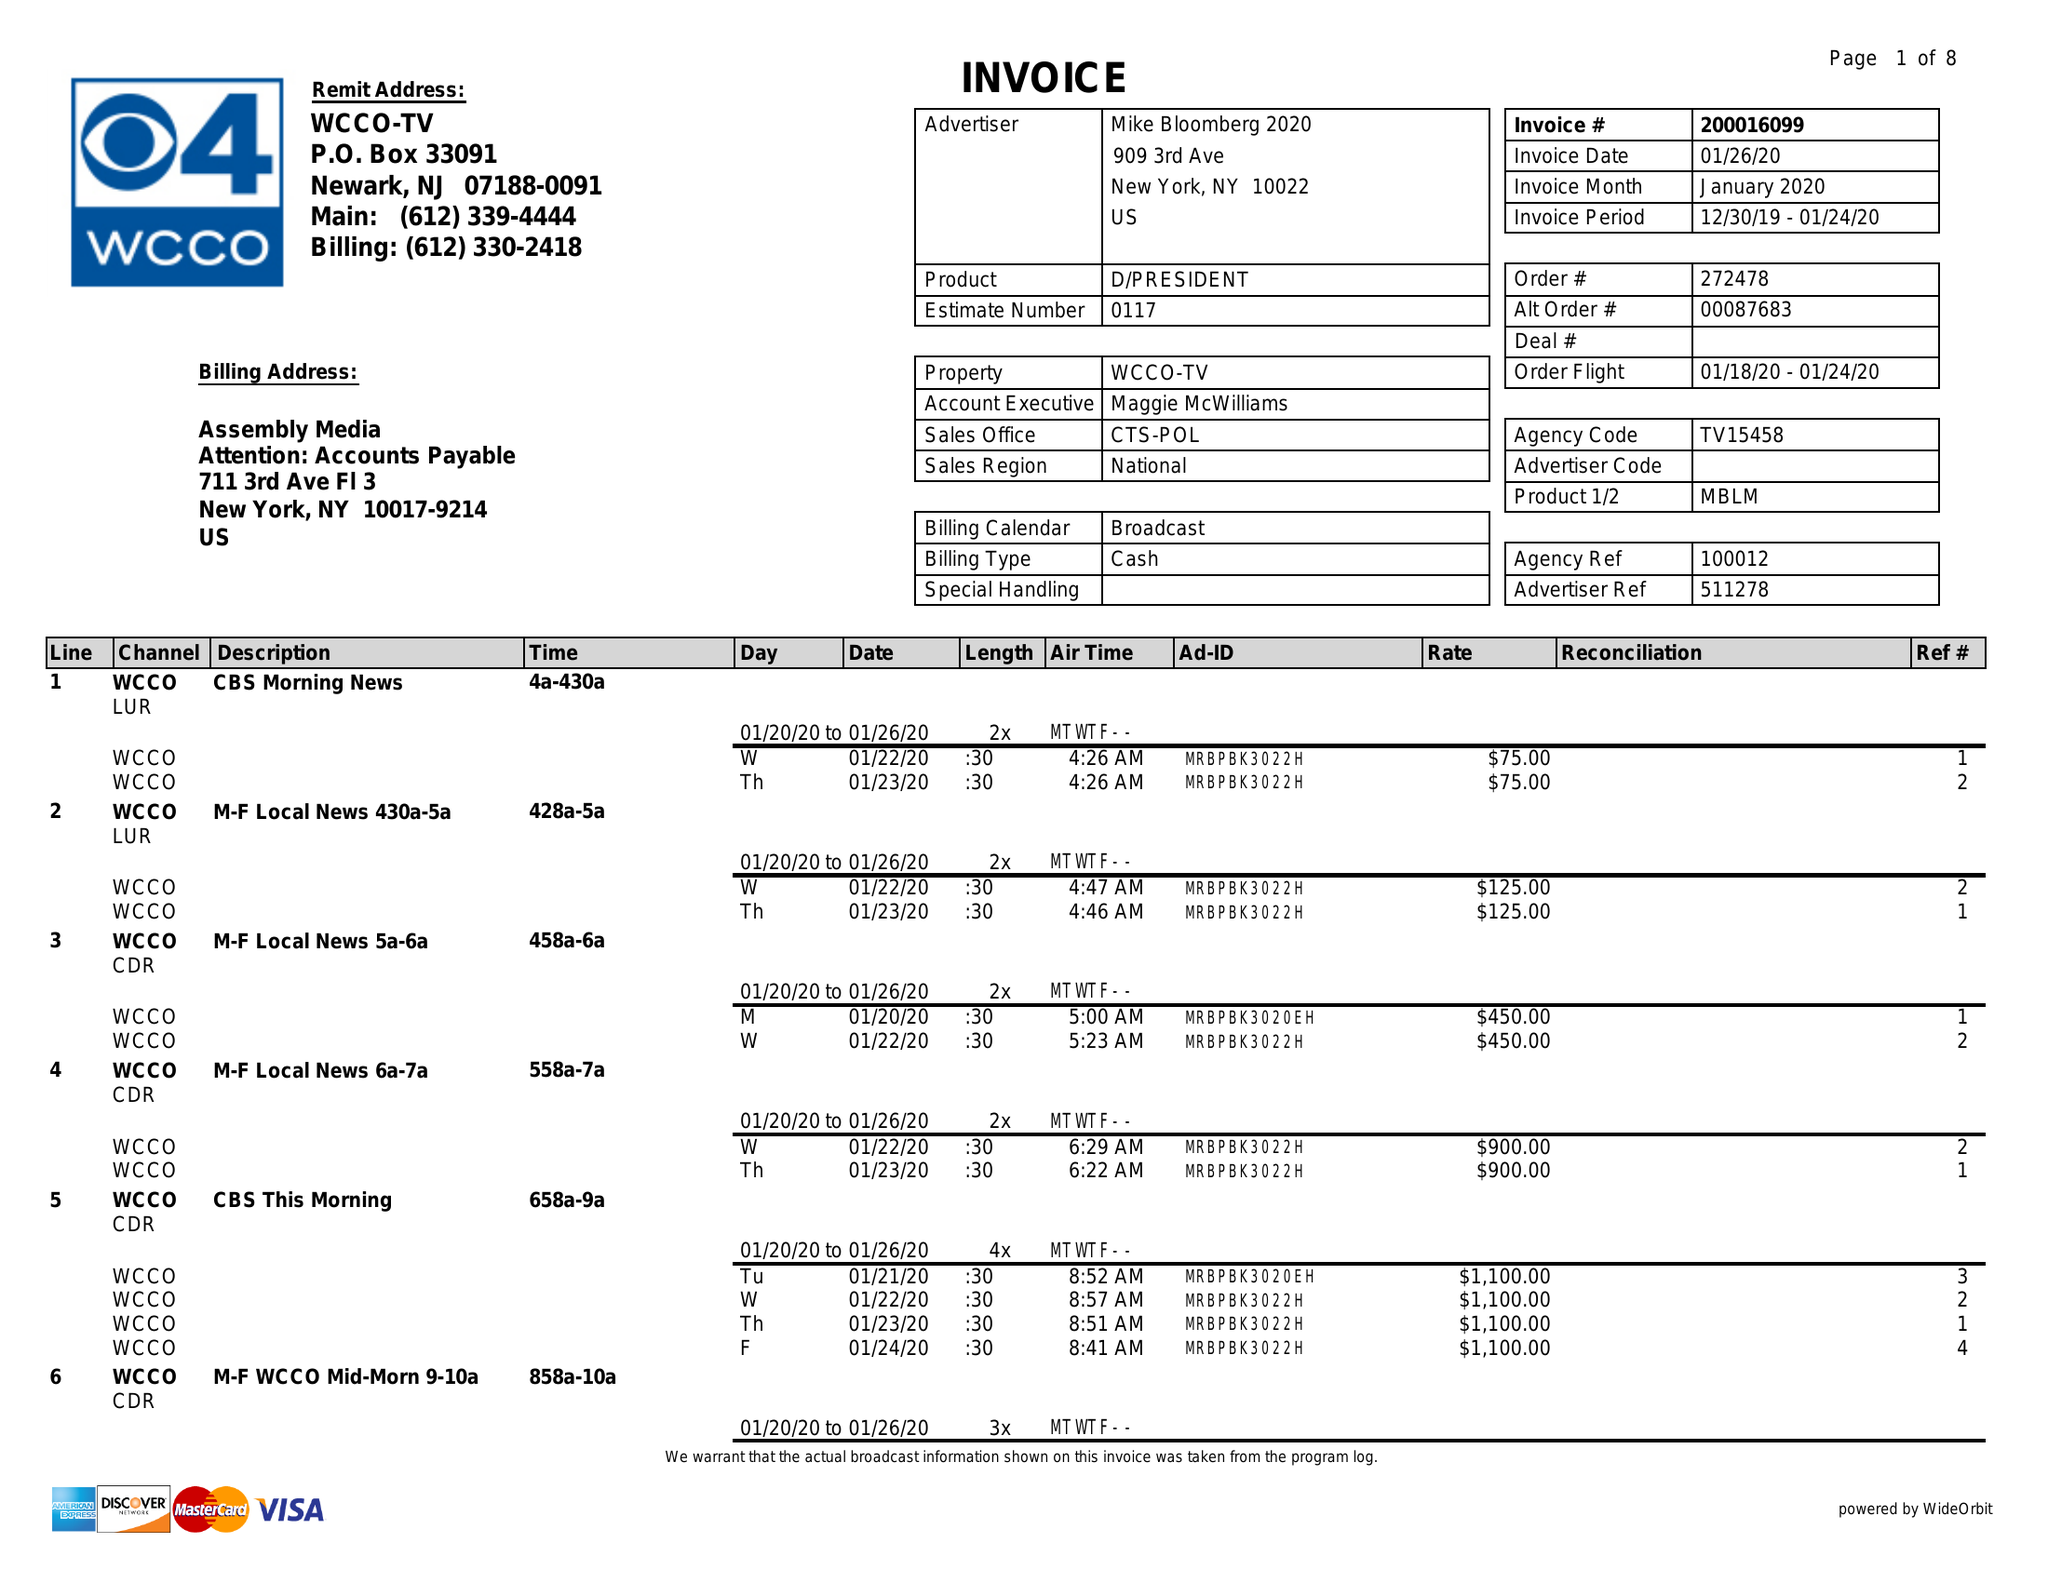What is the value for the advertiser?
Answer the question using a single word or phrase. MIKE BLOOMBERG 2020 